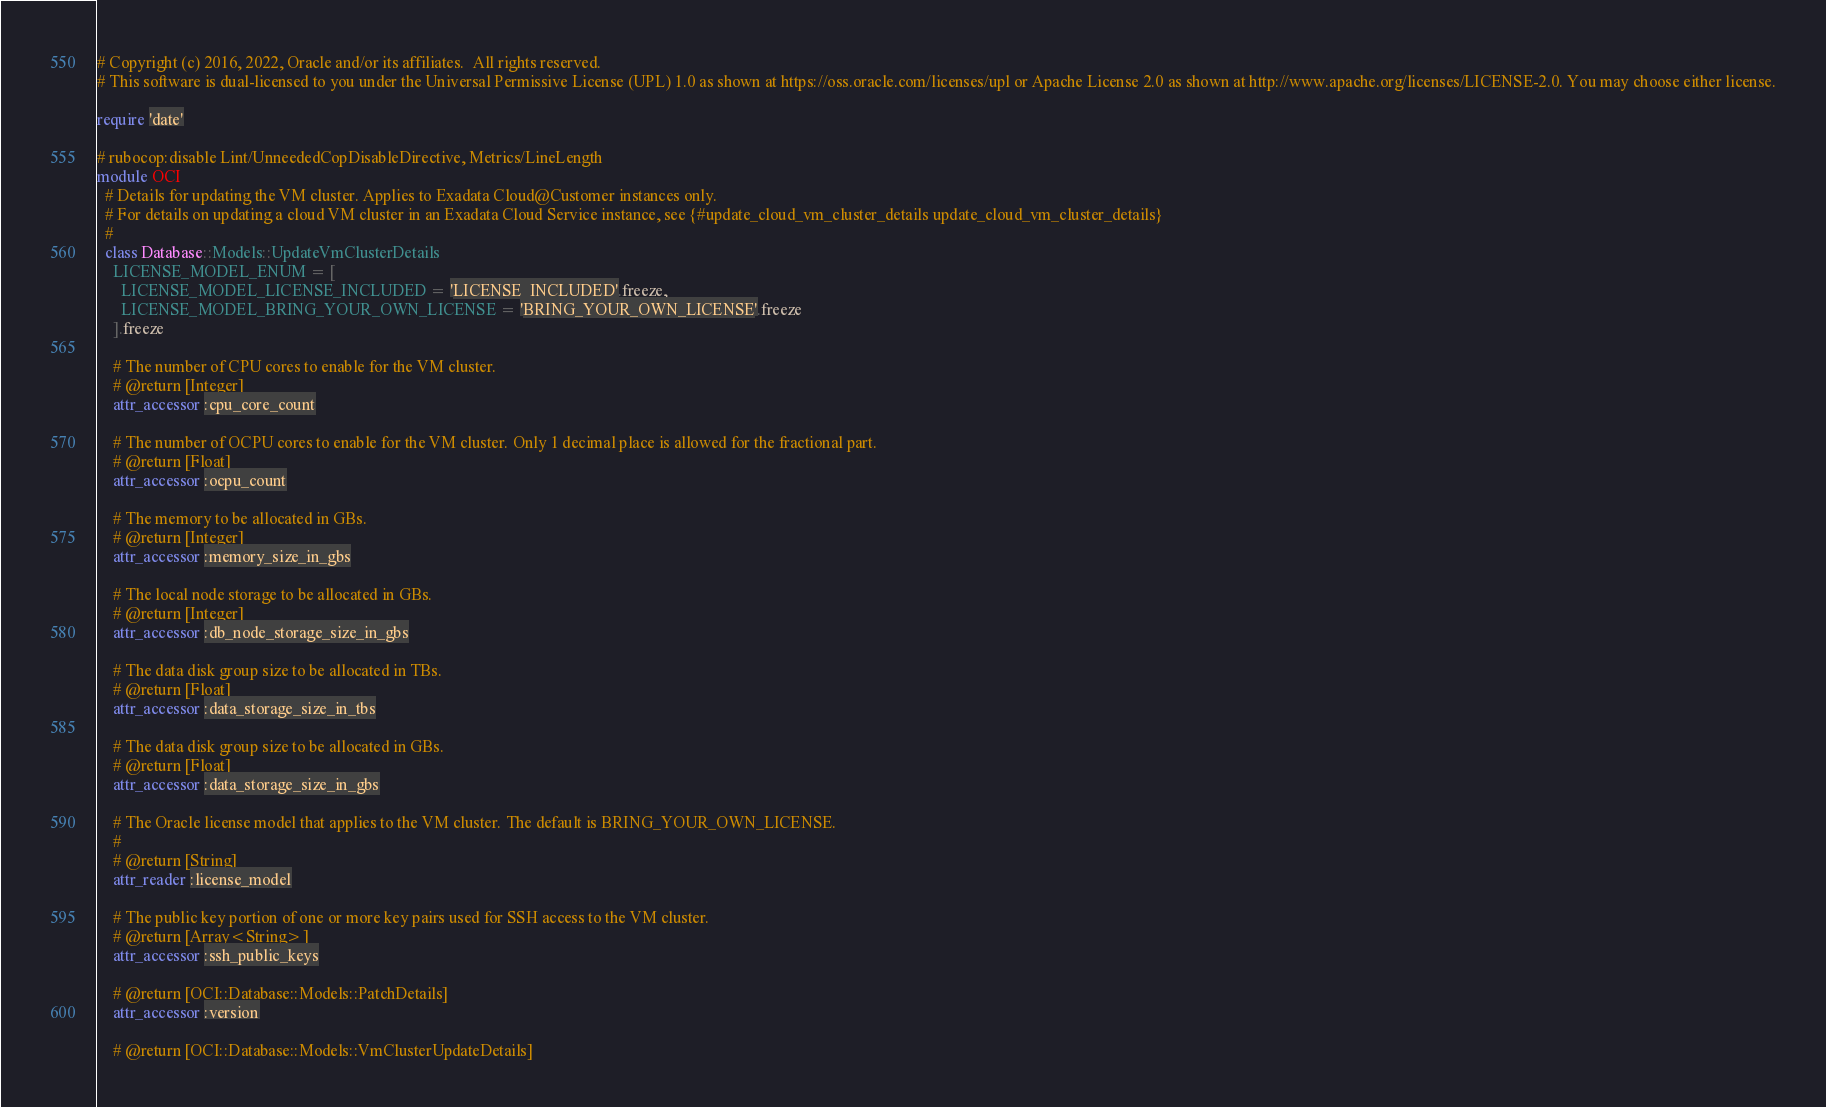<code> <loc_0><loc_0><loc_500><loc_500><_Ruby_># Copyright (c) 2016, 2022, Oracle and/or its affiliates.  All rights reserved.
# This software is dual-licensed to you under the Universal Permissive License (UPL) 1.0 as shown at https://oss.oracle.com/licenses/upl or Apache License 2.0 as shown at http://www.apache.org/licenses/LICENSE-2.0. You may choose either license.

require 'date'

# rubocop:disable Lint/UnneededCopDisableDirective, Metrics/LineLength
module OCI
  # Details for updating the VM cluster. Applies to Exadata Cloud@Customer instances only.
  # For details on updating a cloud VM cluster in an Exadata Cloud Service instance, see {#update_cloud_vm_cluster_details update_cloud_vm_cluster_details}
  #
  class Database::Models::UpdateVmClusterDetails
    LICENSE_MODEL_ENUM = [
      LICENSE_MODEL_LICENSE_INCLUDED = 'LICENSE_INCLUDED'.freeze,
      LICENSE_MODEL_BRING_YOUR_OWN_LICENSE = 'BRING_YOUR_OWN_LICENSE'.freeze
    ].freeze

    # The number of CPU cores to enable for the VM cluster.
    # @return [Integer]
    attr_accessor :cpu_core_count

    # The number of OCPU cores to enable for the VM cluster. Only 1 decimal place is allowed for the fractional part.
    # @return [Float]
    attr_accessor :ocpu_count

    # The memory to be allocated in GBs.
    # @return [Integer]
    attr_accessor :memory_size_in_gbs

    # The local node storage to be allocated in GBs.
    # @return [Integer]
    attr_accessor :db_node_storage_size_in_gbs

    # The data disk group size to be allocated in TBs.
    # @return [Float]
    attr_accessor :data_storage_size_in_tbs

    # The data disk group size to be allocated in GBs.
    # @return [Float]
    attr_accessor :data_storage_size_in_gbs

    # The Oracle license model that applies to the VM cluster. The default is BRING_YOUR_OWN_LICENSE.
    #
    # @return [String]
    attr_reader :license_model

    # The public key portion of one or more key pairs used for SSH access to the VM cluster.
    # @return [Array<String>]
    attr_accessor :ssh_public_keys

    # @return [OCI::Database::Models::PatchDetails]
    attr_accessor :version

    # @return [OCI::Database::Models::VmClusterUpdateDetails]</code> 